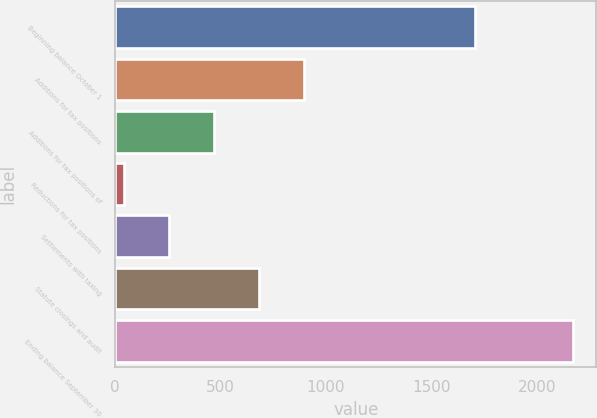Convert chart. <chart><loc_0><loc_0><loc_500><loc_500><bar_chart><fcel>Beginning balance October 1<fcel>Additions for tax positions<fcel>Additions for tax positions of<fcel>Reductions for tax positions<fcel>Settlements with taxing<fcel>Statute closings and audit<fcel>Ending balance September 30<nl><fcel>1706<fcel>895.6<fcel>469.8<fcel>44<fcel>256.9<fcel>682.7<fcel>2173<nl></chart> 